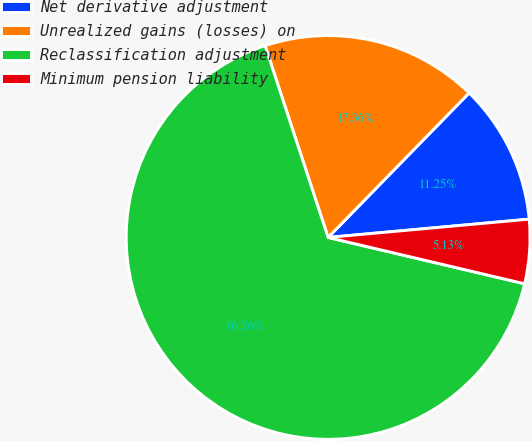Convert chart to OTSL. <chart><loc_0><loc_0><loc_500><loc_500><pie_chart><fcel>Net derivative adjustment<fcel>Unrealized gains (losses) on<fcel>Reclassification adjustment<fcel>Minimum pension liability<nl><fcel>11.25%<fcel>17.36%<fcel>66.26%<fcel>5.13%<nl></chart> 